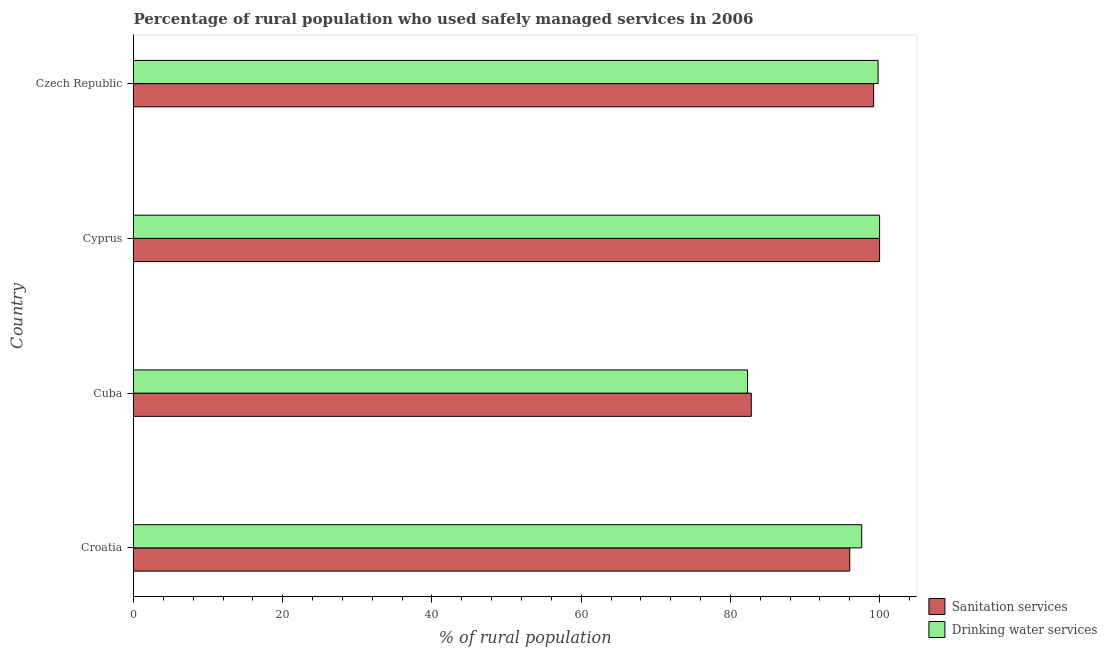How many different coloured bars are there?
Ensure brevity in your answer.  2. How many bars are there on the 3rd tick from the top?
Offer a terse response. 2. What is the label of the 2nd group of bars from the top?
Ensure brevity in your answer.  Cyprus. In how many cases, is the number of bars for a given country not equal to the number of legend labels?
Give a very brief answer. 0. What is the percentage of rural population who used drinking water services in Czech Republic?
Provide a short and direct response. 99.8. Across all countries, what is the maximum percentage of rural population who used sanitation services?
Your answer should be compact. 100. Across all countries, what is the minimum percentage of rural population who used drinking water services?
Offer a terse response. 82.3. In which country was the percentage of rural population who used drinking water services maximum?
Make the answer very short. Cyprus. In which country was the percentage of rural population who used drinking water services minimum?
Your answer should be compact. Cuba. What is the total percentage of rural population who used drinking water services in the graph?
Give a very brief answer. 379.7. What is the difference between the percentage of rural population who used drinking water services in Croatia and the percentage of rural population who used sanitation services in Cyprus?
Offer a very short reply. -2.4. What is the average percentage of rural population who used drinking water services per country?
Offer a very short reply. 94.92. What is the ratio of the percentage of rural population who used drinking water services in Croatia to that in Cuba?
Keep it short and to the point. 1.19. What is the difference between the highest and the second highest percentage of rural population who used sanitation services?
Ensure brevity in your answer.  0.8. Is the sum of the percentage of rural population who used drinking water services in Cuba and Cyprus greater than the maximum percentage of rural population who used sanitation services across all countries?
Your answer should be compact. Yes. What does the 1st bar from the top in Cuba represents?
Your answer should be very brief. Drinking water services. What does the 1st bar from the bottom in Cuba represents?
Provide a succinct answer. Sanitation services. How many bars are there?
Provide a succinct answer. 8. Are all the bars in the graph horizontal?
Ensure brevity in your answer.  Yes. How many countries are there in the graph?
Your response must be concise. 4. What is the difference between two consecutive major ticks on the X-axis?
Provide a short and direct response. 20. Are the values on the major ticks of X-axis written in scientific E-notation?
Offer a terse response. No. Does the graph contain grids?
Your answer should be compact. No. Where does the legend appear in the graph?
Provide a succinct answer. Bottom right. How are the legend labels stacked?
Offer a terse response. Vertical. What is the title of the graph?
Provide a short and direct response. Percentage of rural population who used safely managed services in 2006. What is the label or title of the X-axis?
Give a very brief answer. % of rural population. What is the label or title of the Y-axis?
Provide a succinct answer. Country. What is the % of rural population in Sanitation services in Croatia?
Make the answer very short. 96. What is the % of rural population in Drinking water services in Croatia?
Ensure brevity in your answer.  97.6. What is the % of rural population of Sanitation services in Cuba?
Your response must be concise. 82.8. What is the % of rural population of Drinking water services in Cuba?
Make the answer very short. 82.3. What is the % of rural population in Sanitation services in Czech Republic?
Provide a succinct answer. 99.2. What is the % of rural population of Drinking water services in Czech Republic?
Your answer should be very brief. 99.8. Across all countries, what is the maximum % of rural population in Drinking water services?
Provide a succinct answer. 100. Across all countries, what is the minimum % of rural population in Sanitation services?
Provide a short and direct response. 82.8. Across all countries, what is the minimum % of rural population in Drinking water services?
Provide a short and direct response. 82.3. What is the total % of rural population in Sanitation services in the graph?
Offer a terse response. 378. What is the total % of rural population of Drinking water services in the graph?
Keep it short and to the point. 379.7. What is the difference between the % of rural population in Drinking water services in Croatia and that in Cuba?
Make the answer very short. 15.3. What is the difference between the % of rural population in Drinking water services in Croatia and that in Cyprus?
Your answer should be compact. -2.4. What is the difference between the % of rural population in Sanitation services in Cuba and that in Cyprus?
Provide a succinct answer. -17.2. What is the difference between the % of rural population of Drinking water services in Cuba and that in Cyprus?
Offer a very short reply. -17.7. What is the difference between the % of rural population in Sanitation services in Cuba and that in Czech Republic?
Provide a short and direct response. -16.4. What is the difference between the % of rural population of Drinking water services in Cuba and that in Czech Republic?
Your answer should be very brief. -17.5. What is the difference between the % of rural population of Sanitation services in Cyprus and that in Czech Republic?
Offer a terse response. 0.8. What is the difference between the % of rural population of Sanitation services in Cuba and the % of rural population of Drinking water services in Cyprus?
Offer a terse response. -17.2. What is the difference between the % of rural population of Sanitation services in Cuba and the % of rural population of Drinking water services in Czech Republic?
Your answer should be compact. -17. What is the average % of rural population in Sanitation services per country?
Offer a terse response. 94.5. What is the average % of rural population of Drinking water services per country?
Give a very brief answer. 94.92. What is the difference between the % of rural population in Sanitation services and % of rural population in Drinking water services in Czech Republic?
Make the answer very short. -0.6. What is the ratio of the % of rural population in Sanitation services in Croatia to that in Cuba?
Provide a short and direct response. 1.16. What is the ratio of the % of rural population in Drinking water services in Croatia to that in Cuba?
Ensure brevity in your answer.  1.19. What is the ratio of the % of rural population of Sanitation services in Croatia to that in Czech Republic?
Ensure brevity in your answer.  0.97. What is the ratio of the % of rural population in Drinking water services in Croatia to that in Czech Republic?
Provide a short and direct response. 0.98. What is the ratio of the % of rural population of Sanitation services in Cuba to that in Cyprus?
Your response must be concise. 0.83. What is the ratio of the % of rural population in Drinking water services in Cuba to that in Cyprus?
Your response must be concise. 0.82. What is the ratio of the % of rural population in Sanitation services in Cuba to that in Czech Republic?
Keep it short and to the point. 0.83. What is the ratio of the % of rural population in Drinking water services in Cuba to that in Czech Republic?
Offer a very short reply. 0.82. What is the ratio of the % of rural population of Sanitation services in Cyprus to that in Czech Republic?
Your response must be concise. 1.01. What is the difference between the highest and the second highest % of rural population in Drinking water services?
Ensure brevity in your answer.  0.2. What is the difference between the highest and the lowest % of rural population in Drinking water services?
Offer a very short reply. 17.7. 